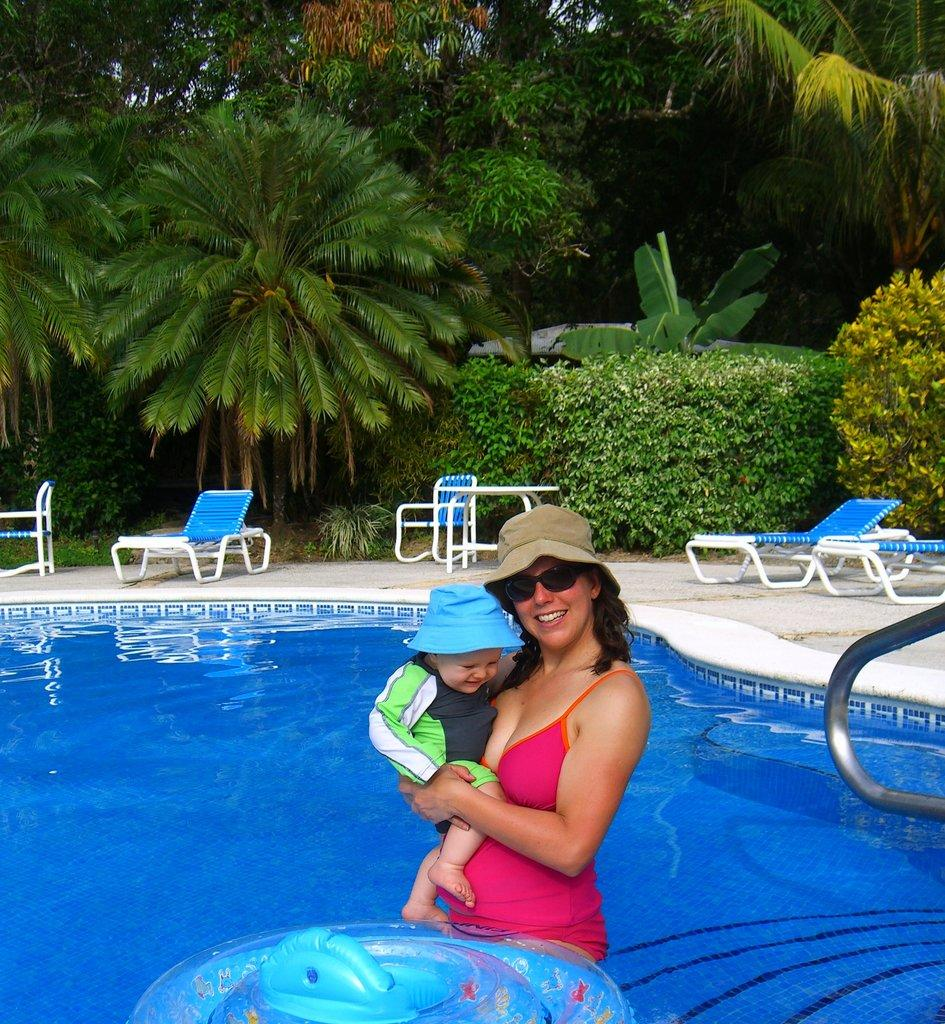Who is the main subject in the image? There is a woman in the image. What is the woman holding? The woman is holding a baby. Who is the woman looking at? The woman is looking at someone. What is the setting of the image? The woman is standing in a pool of water. What type of vegetation can be seen in the image? Plants and trees are present in the image. What type of quilt is covering the flesh of the baby in the image? There is no quilt or mention of the baby's flesh in the image; the woman is simply holding a baby. 